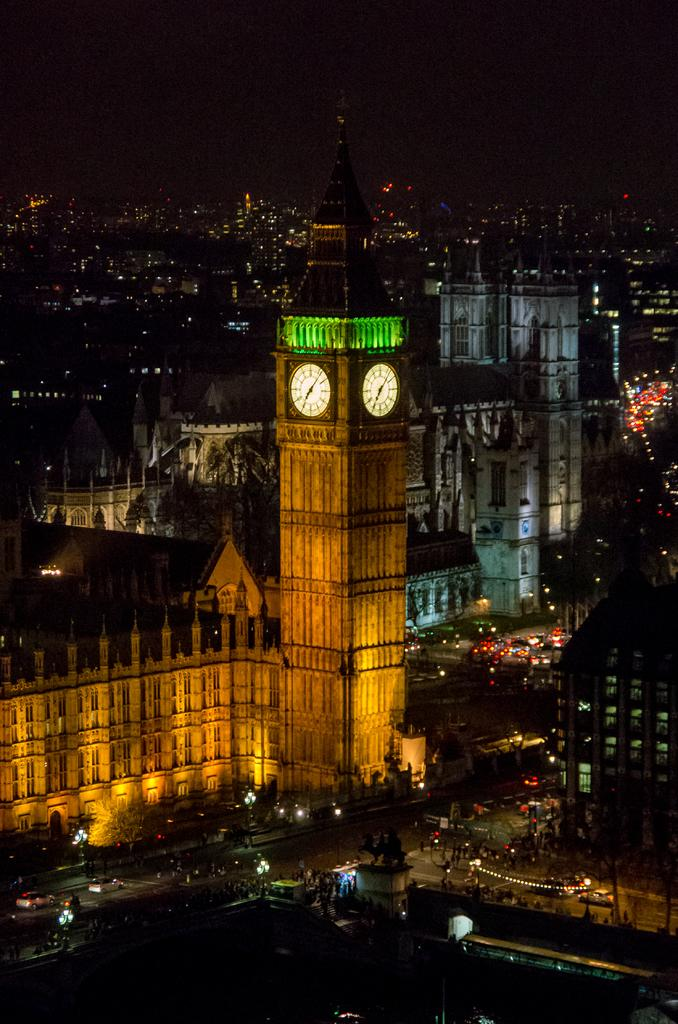What type of infrastructure can be seen in the image? There are roads in the image. What other objects are visible in the image? There are lights, multiple buildings, and a clock tower in the image. Can you describe the lighting conditions in the image? The image appears to be slightly dark. What type of list can be seen hanging on the clock tower in the image? There is no list present in the image, and the clock tower is not mentioned as having any additional objects hanging from it. 